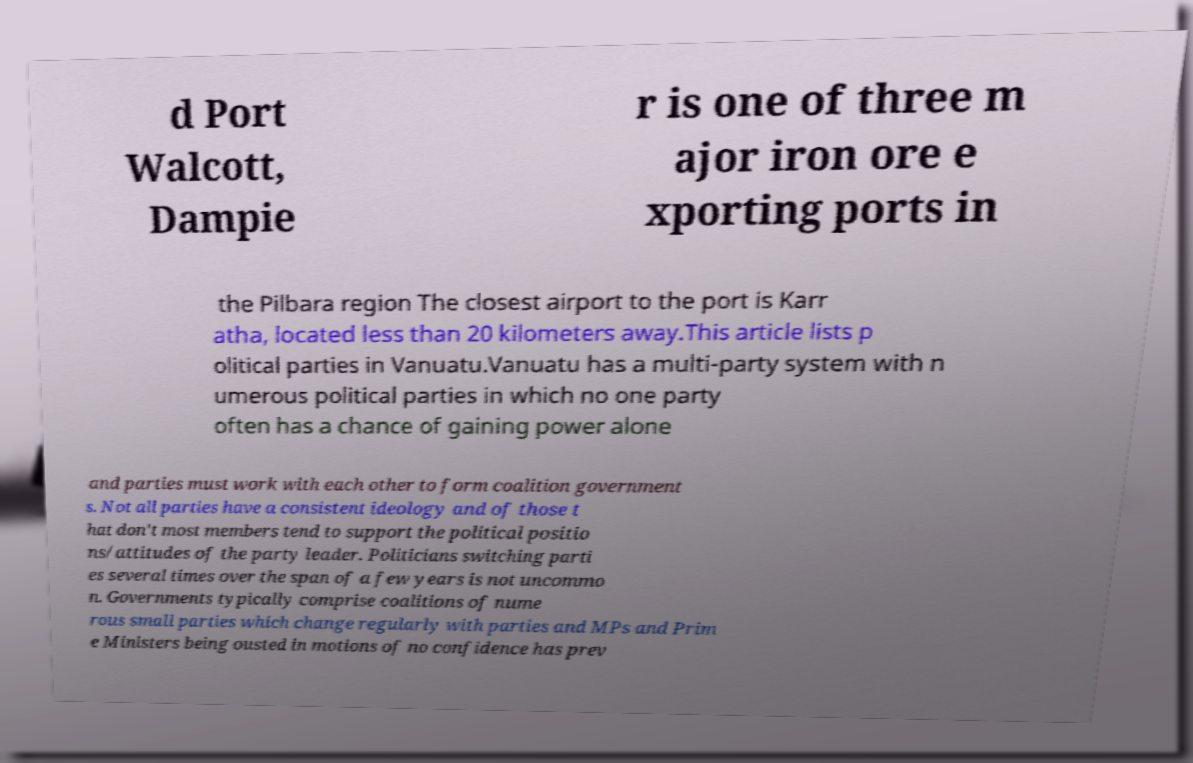Could you extract and type out the text from this image? d Port Walcott, Dampie r is one of three m ajor iron ore e xporting ports in the Pilbara region The closest airport to the port is Karr atha, located less than 20 kilometers away.This article lists p olitical parties in Vanuatu.Vanuatu has a multi-party system with n umerous political parties in which no one party often has a chance of gaining power alone and parties must work with each other to form coalition government s. Not all parties have a consistent ideology and of those t hat don't most members tend to support the political positio ns/attitudes of the party leader. Politicians switching parti es several times over the span of a few years is not uncommo n. Governments typically comprise coalitions of nume rous small parties which change regularly with parties and MPs and Prim e Ministers being ousted in motions of no confidence has prev 